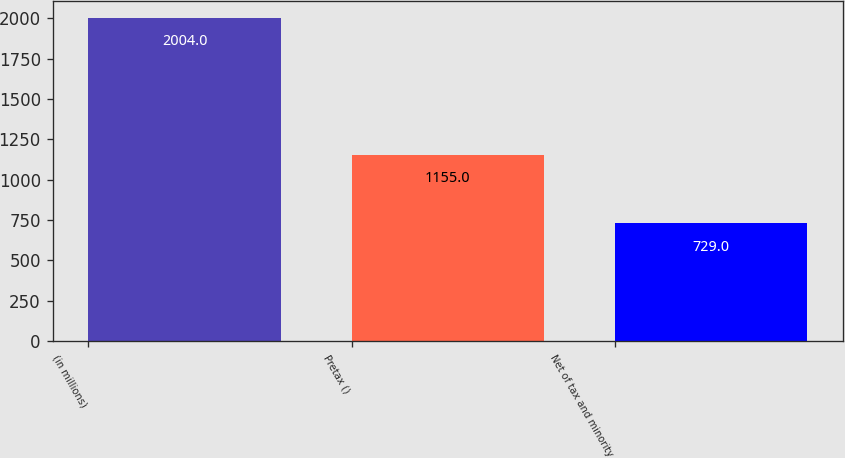Convert chart to OTSL. <chart><loc_0><loc_0><loc_500><loc_500><bar_chart><fcel>(in millions)<fcel>Pretax ()<fcel>Net of tax and minority<nl><fcel>2004<fcel>1155<fcel>729<nl></chart> 